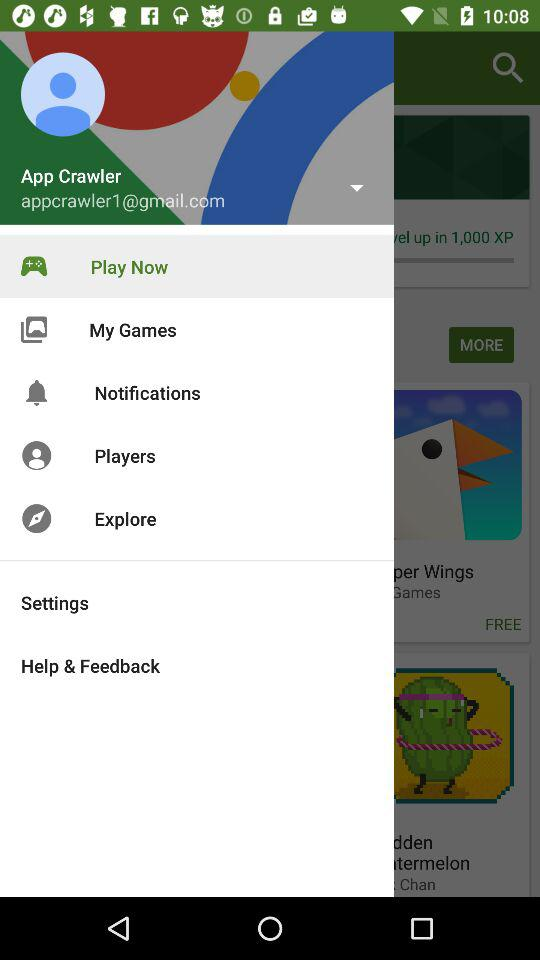What is the name of the person? The name of the person is App Crawler. 